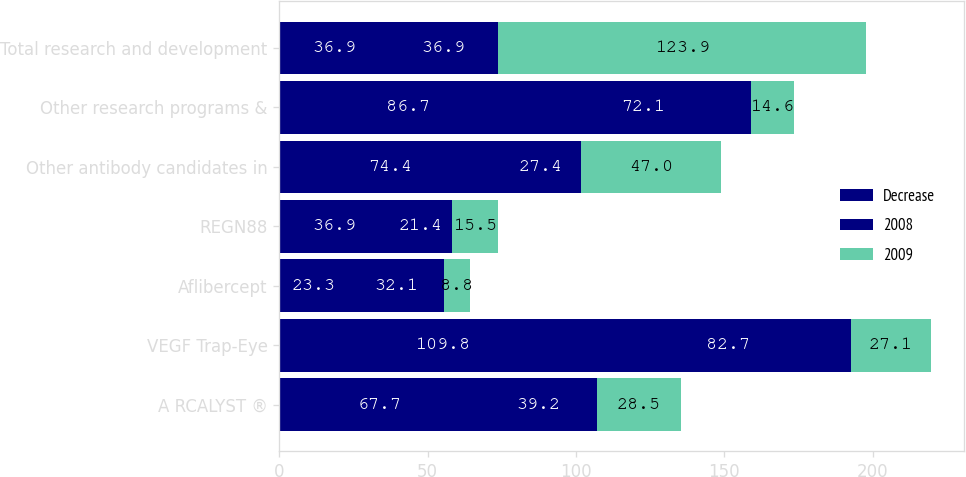Convert chart to OTSL. <chart><loc_0><loc_0><loc_500><loc_500><stacked_bar_chart><ecel><fcel>A RCALYST ®<fcel>VEGF Trap-Eye<fcel>Aflibercept<fcel>REGN88<fcel>Other antibody candidates in<fcel>Other research programs &<fcel>Total research and development<nl><fcel>Decrease<fcel>67.7<fcel>109.8<fcel>23.3<fcel>36.9<fcel>74.4<fcel>86.7<fcel>36.9<nl><fcel>2008<fcel>39.2<fcel>82.7<fcel>32.1<fcel>21.4<fcel>27.4<fcel>72.1<fcel>36.9<nl><fcel>2009<fcel>28.5<fcel>27.1<fcel>8.8<fcel>15.5<fcel>47<fcel>14.6<fcel>123.9<nl></chart> 